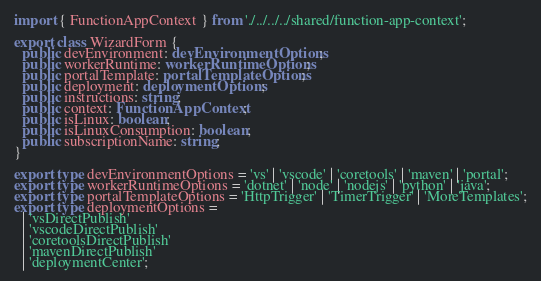Convert code to text. <code><loc_0><loc_0><loc_500><loc_500><_TypeScript_>import { FunctionAppContext } from './../../../shared/function-app-context';

export class WizardForm {
  public devEnvironment: devEnvironmentOptions;
  public workerRuntime: workerRuntimeOptions;
  public portalTemplate: portalTemplateOptions;
  public deployment: deploymentOptions;
  public instructions: string;
  public context: FunctionAppContext;
  public isLinux: boolean;
  public isLinuxConsumption: boolean;
  public subscriptionName: string;
}

export type devEnvironmentOptions = 'vs' | 'vscode' | 'coretools' | 'maven' | 'portal';
export type workerRuntimeOptions = 'dotnet' | 'node' | 'nodejs' | 'python' | 'java';
export type portalTemplateOptions = 'HttpTrigger' | 'TimerTrigger' | 'MoreTemplates';
export type deploymentOptions =
  | 'vsDirectPublish'
  | 'vscodeDirectPublish'
  | 'coretoolsDirectPublish'
  | 'mavenDirectPublish'
  | 'deploymentCenter';
</code> 